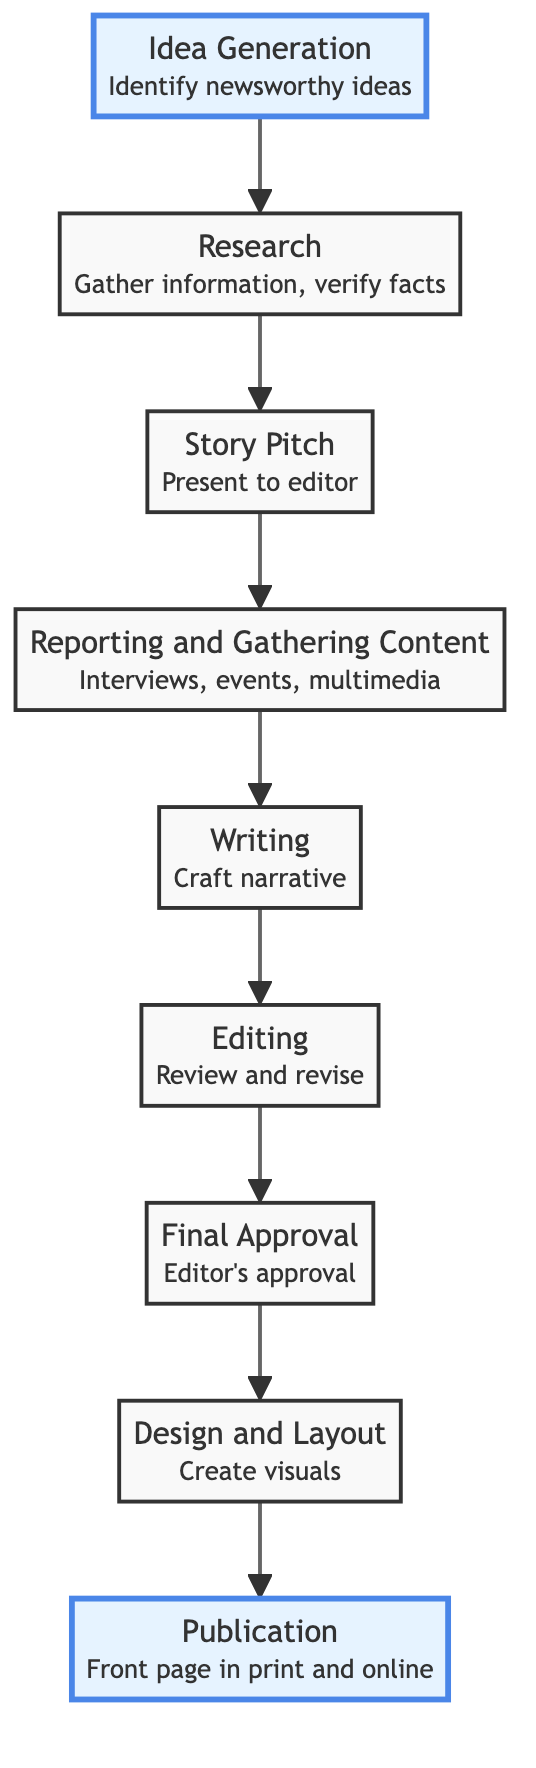What is the highest level in the flow chart? The flow chart shows a progression from "Idea Generation" at level 1 to "Publication" at level 9. The highest level is therefore level 9, which corresponds to "Publication".
Answer: Publication How many total steps are there in the feature story development? Counting each step from "Idea Generation" to "Publication," there are 9 distinct nodes in the flow chart. Therefore, there are 9 steps in total.
Answer: 9 What is the title of the second step? The second node in the flow chart is "Research". This can be confirmed by looking at the arrow leading upward from "Idea Generation" to the next node.
Answer: Research Which step comes immediately after "Editing"? By following the upward flow of the chart, "Final Approval" is the node that comes directly after "Editing". This is based on the sequence of arrows indicating the order of steps.
Answer: Final Approval What is the main task during the "Writing" phase? According to the flow chart, the main task during the "Writing" phase is to "Craft a well-structured narrative". This detail is directly stated in the description of the "Writing" node.
Answer: Craft a well-structured narrative What step involves the design team? The step that involves the design team is "Design and Layout". It is explicitly stated in the description of that node, indicating that collaboration with the design team occurs here.
Answer: Design and Layout Which step is the starting point of the flow chart? The starting point is indicated by the bottom node, which is "Idea Generation". This is the first step shown in the flow, as all other steps build upon it.
Answer: Idea Generation What is necessary before obtaining "Final Approval"? Before receiving "Final Approval", the step of "Editing" must be completed, as this step includes the submission for editorial review and necessary revisions.
Answer: Editing What comes before "Publication"? The step leading directly before "Publication" is "Design and Layout", as shown by the upward flow of the diagram from that node to the final publication stage.
Answer: Design and Layout 